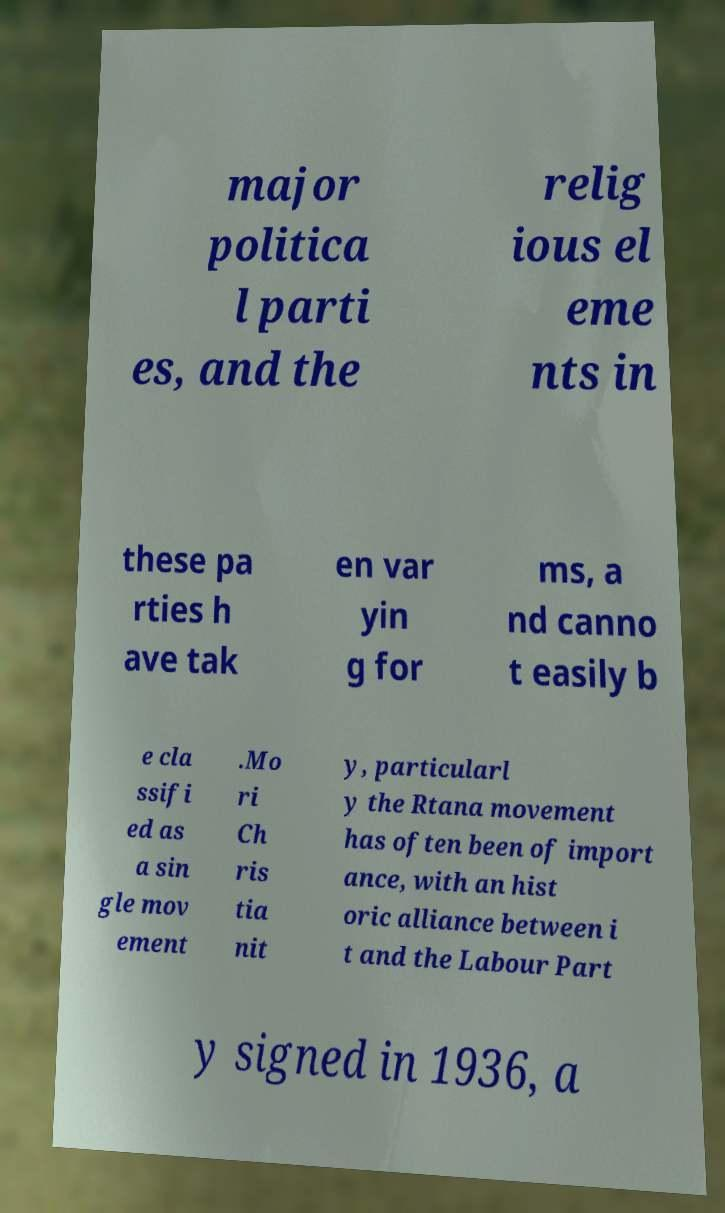Can you accurately transcribe the text from the provided image for me? major politica l parti es, and the relig ious el eme nts in these pa rties h ave tak en var yin g for ms, a nd canno t easily b e cla ssifi ed as a sin gle mov ement .Mo ri Ch ris tia nit y, particularl y the Rtana movement has often been of import ance, with an hist oric alliance between i t and the Labour Part y signed in 1936, a 